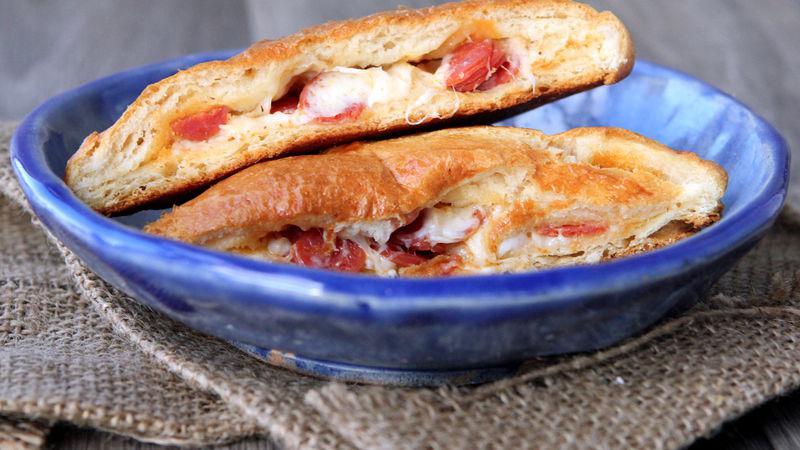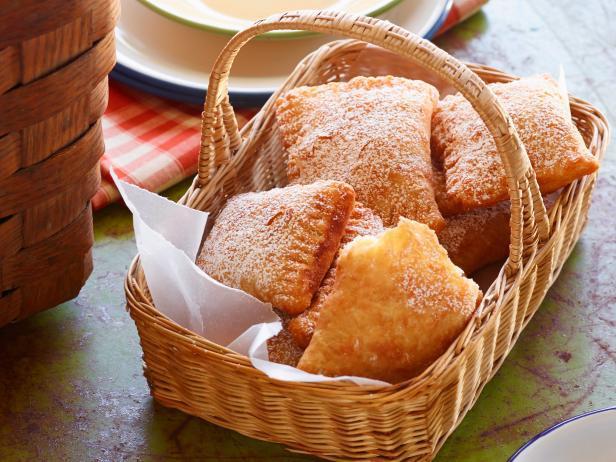The first image is the image on the left, the second image is the image on the right. Considering the images on both sides, is "In the left image the food is on a white plate." valid? Answer yes or no. No. 